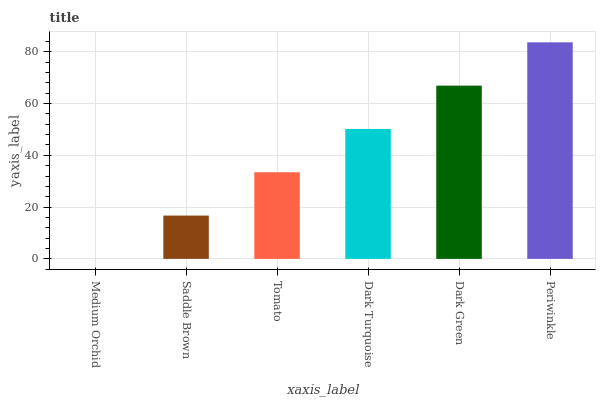Is Saddle Brown the minimum?
Answer yes or no. No. Is Saddle Brown the maximum?
Answer yes or no. No. Is Saddle Brown greater than Medium Orchid?
Answer yes or no. Yes. Is Medium Orchid less than Saddle Brown?
Answer yes or no. Yes. Is Medium Orchid greater than Saddle Brown?
Answer yes or no. No. Is Saddle Brown less than Medium Orchid?
Answer yes or no. No. Is Dark Turquoise the high median?
Answer yes or no. Yes. Is Tomato the low median?
Answer yes or no. Yes. Is Saddle Brown the high median?
Answer yes or no. No. Is Saddle Brown the low median?
Answer yes or no. No. 